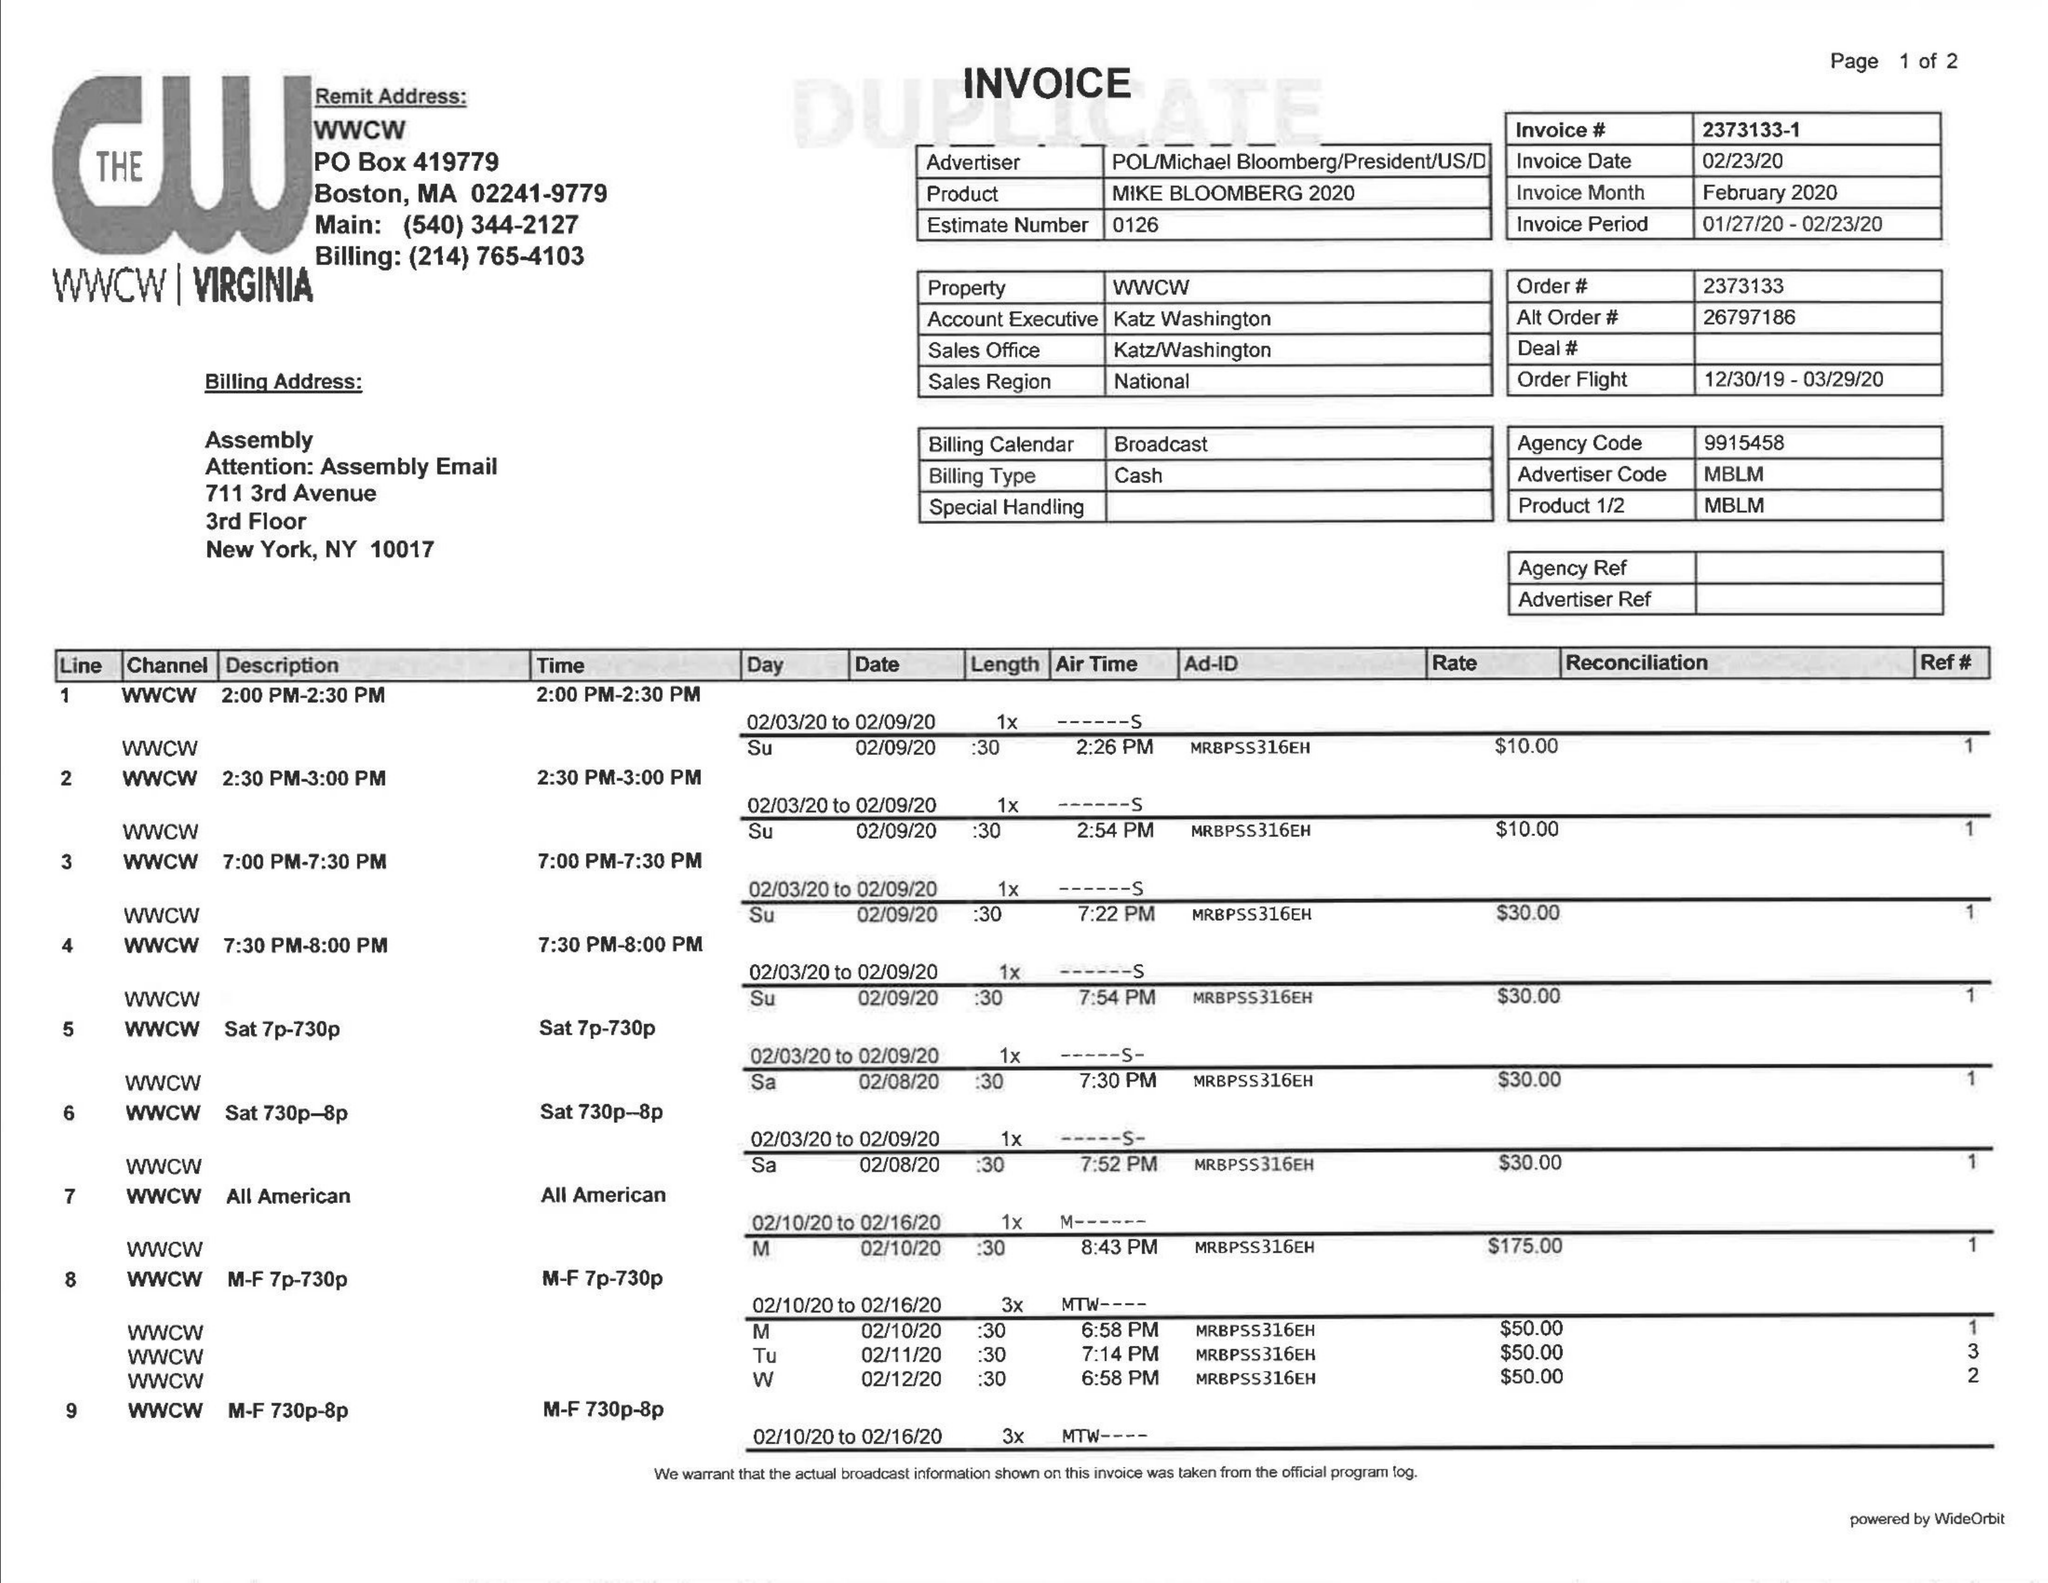What is the value for the advertiser?
Answer the question using a single word or phrase. POL/MICHAELBLOOMBERG/PRESIDEN/US/D 